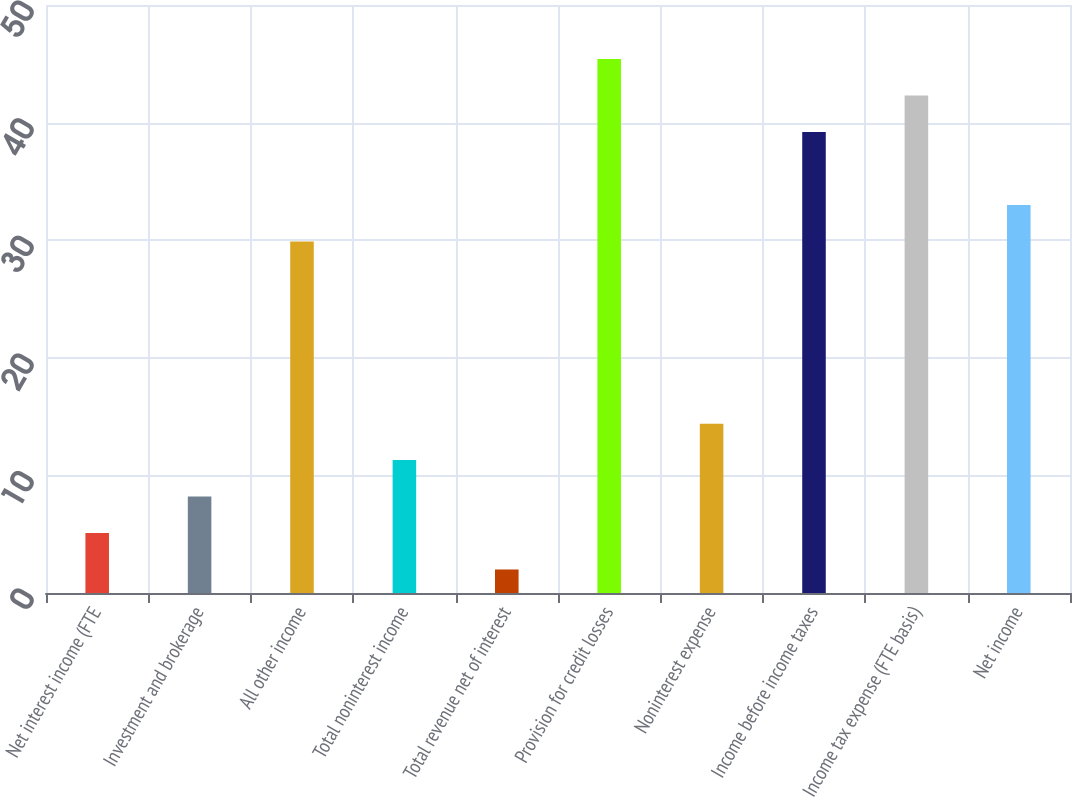<chart> <loc_0><loc_0><loc_500><loc_500><bar_chart><fcel>Net interest income (FTE<fcel>Investment and brokerage<fcel>All other income<fcel>Total noninterest income<fcel>Total revenue net of interest<fcel>Provision for credit losses<fcel>Noninterest expense<fcel>Income before income taxes<fcel>Income tax expense (FTE basis)<fcel>Net income<nl><fcel>5.1<fcel>8.2<fcel>29.9<fcel>11.3<fcel>2<fcel>45.4<fcel>14.4<fcel>39.2<fcel>42.3<fcel>33<nl></chart> 